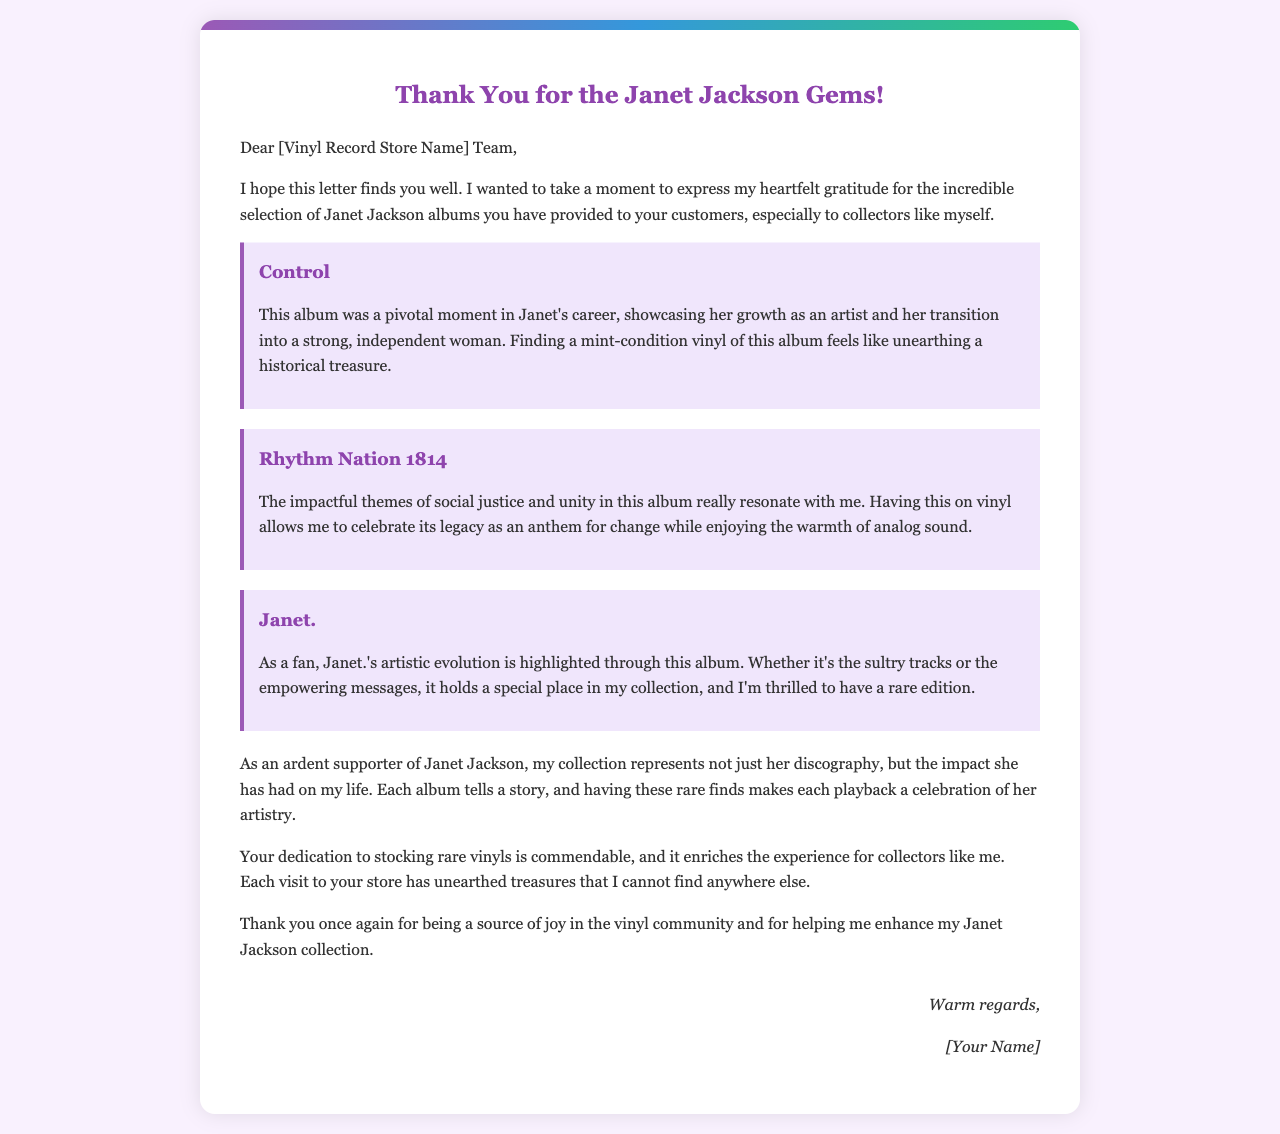What albums are mentioned in the letter? The letter lists three Janet Jackson albums: "Control," "Rhythm Nation 1814," and "Janet."
Answer: Control, Rhythm Nation 1814, Janet What is the significance of the album "Control"? The album "Control" represents a pivotal moment in Janet's career and her growth as an artist.
Answer: Growth as an artist What themes are discussed in "Rhythm Nation 1814"? The letter highlights themes of social justice and unity found in the album "Rhythm Nation 1814."
Answer: Social justice and unity What feeling does the author express about their collection? The author expresses that their collection represents the impact Janet Jackson has had on their life.
Answer: Impact on life Who is the letter addressed to? The letter is addressed to the [Vinyl Record Store Name] Team, specific name not provided.
Answer: [Vinyl Record Store Name] Team What type of vinyl records does the author appreciate? The author appreciates rare Janet Jackson vinyl records as part of their collection.
Answer: Rare Janet Jackson vinyl records How does the author describe their experience visiting the store? The author describes their visits as unearthing treasures that cannot be found elsewhere.
Answer: Unearthing treasures What emotions does the author communicate towards the store's efforts? The author communicates gratitude towards the store's dedication to stocking rare vinyls.
Answer: Gratitude 